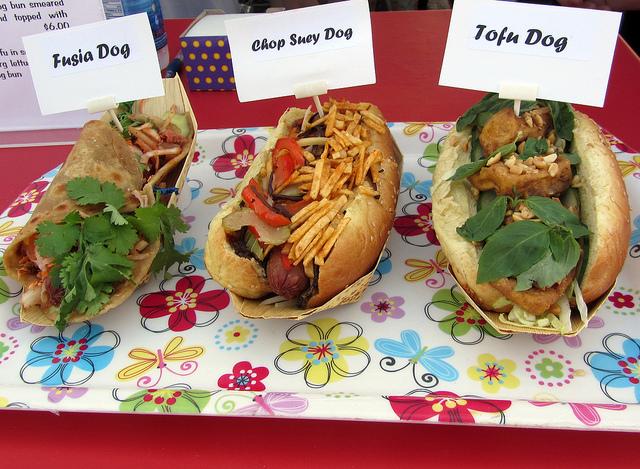What kind of food is shown?
Answer briefly. Hot dog. What would this business specialize in?
Concise answer only. Hot dogs. What is on the chop suey dog?
Short answer required. French fries and vegetables. What do the cards say?
Keep it brief. Dog. What is the name of the dog on the right?
Answer briefly. Tofu dog. Are these normal hot dogs?
Write a very short answer. No. 